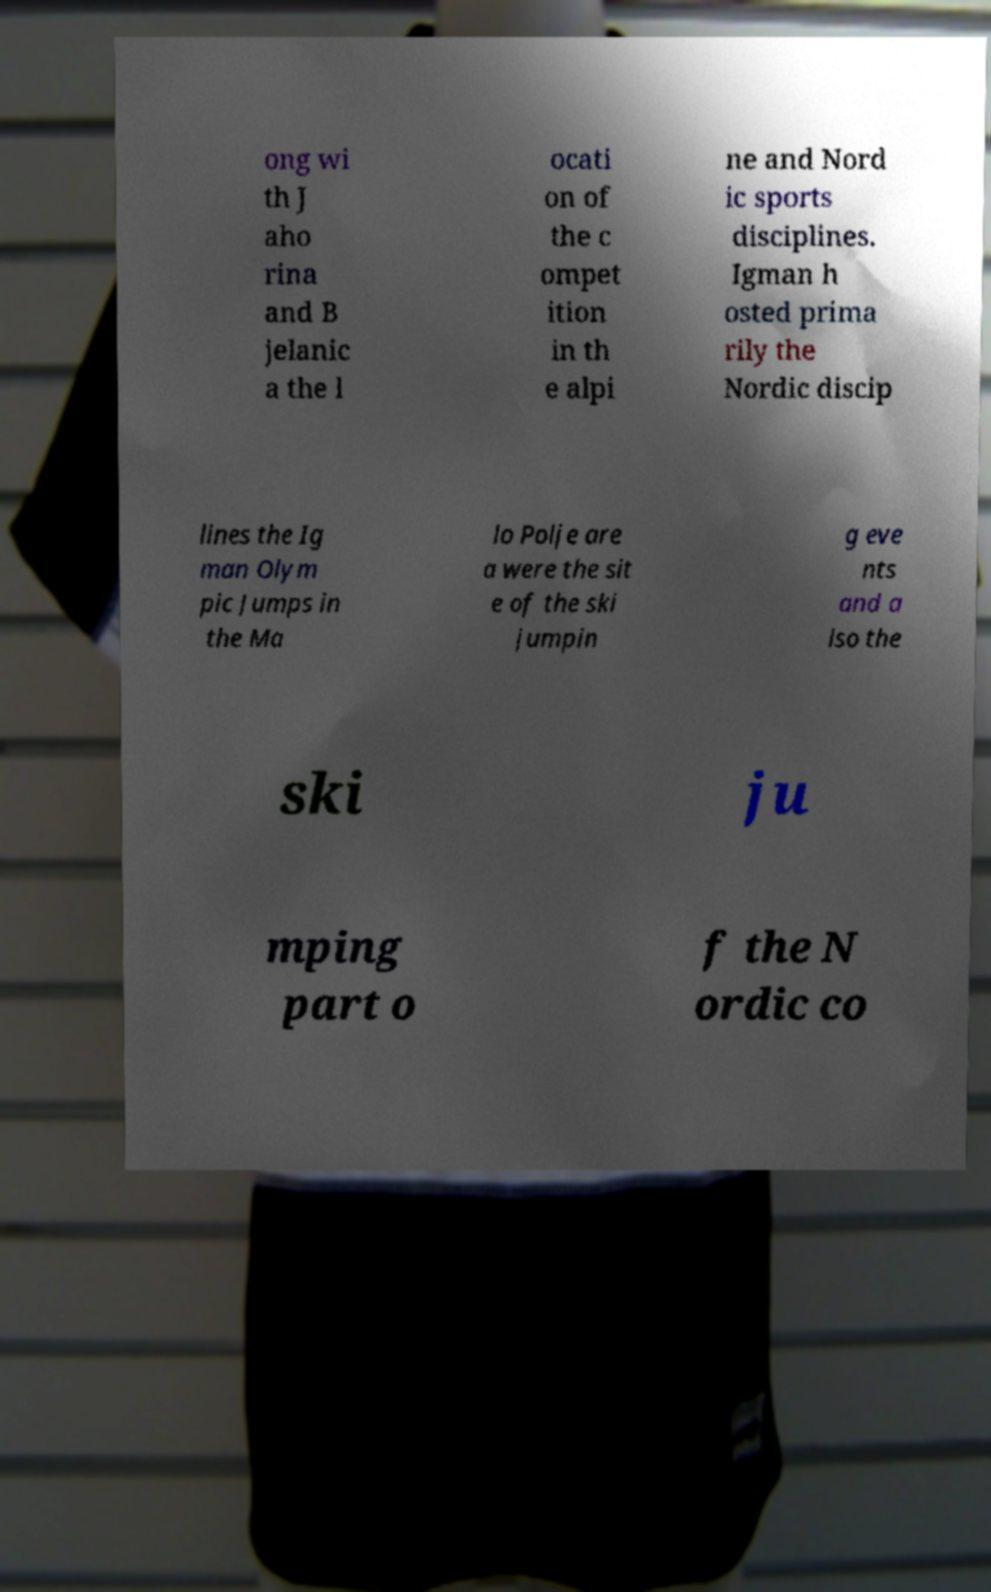Could you extract and type out the text from this image? ong wi th J aho rina and B jelanic a the l ocati on of the c ompet ition in th e alpi ne and Nord ic sports disciplines. Igman h osted prima rily the Nordic discip lines the Ig man Olym pic Jumps in the Ma lo Polje are a were the sit e of the ski jumpin g eve nts and a lso the ski ju mping part o f the N ordic co 